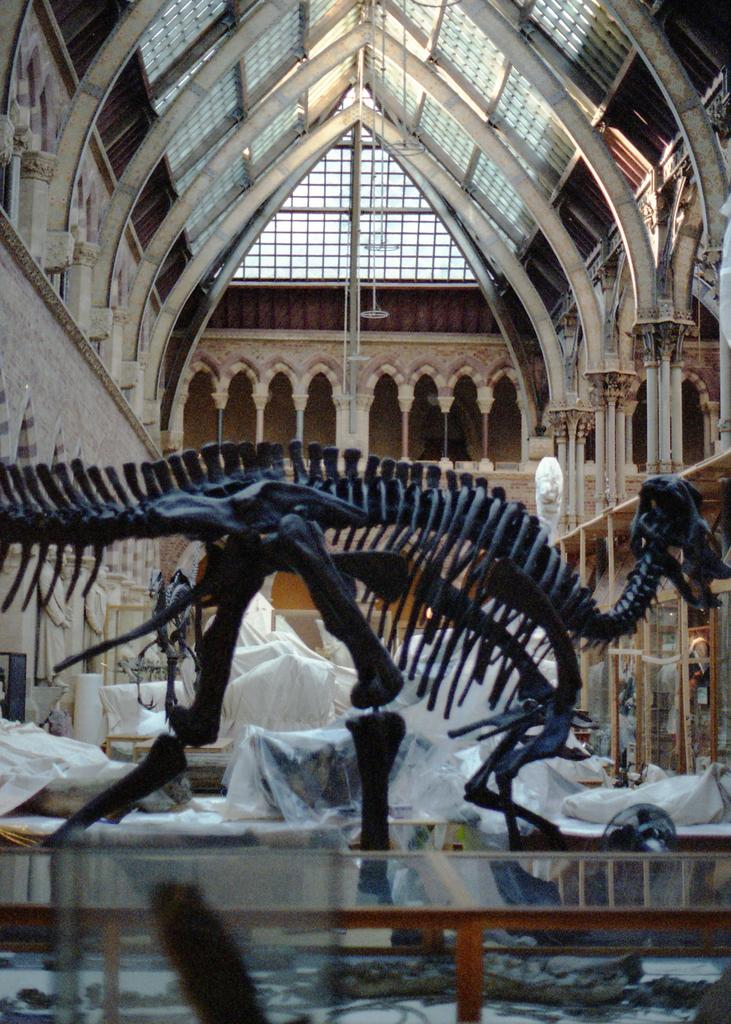What type of establishment is depicted in the image? The image contains a museum. What can be found within the museum in the image? There is a skeleton of an animal in the image. What is used to display the animal skeleton in the image? There is a showcase box in the image. What type of turkey is being served at the feast in the image? There is no feast or turkey present in the image; it contains a museum with an animal skeleton in a showcase box. 